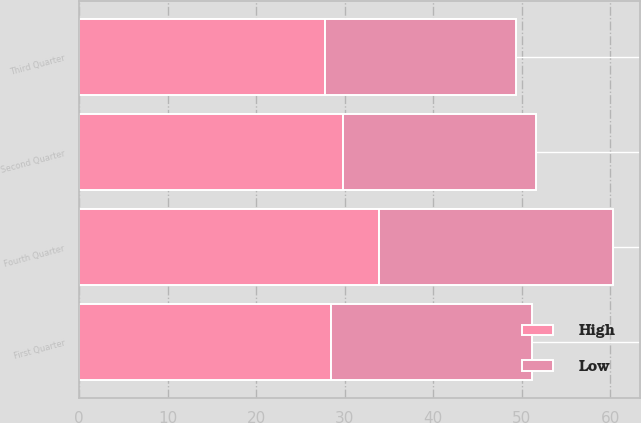Convert chart to OTSL. <chart><loc_0><loc_0><loc_500><loc_500><stacked_bar_chart><ecel><fcel>First Quarter<fcel>Second Quarter<fcel>Third Quarter<fcel>Fourth Quarter<nl><fcel>High<fcel>28.48<fcel>29.75<fcel>27.72<fcel>33.83<nl><fcel>Low<fcel>22.71<fcel>21.81<fcel>21.64<fcel>26.53<nl></chart> 